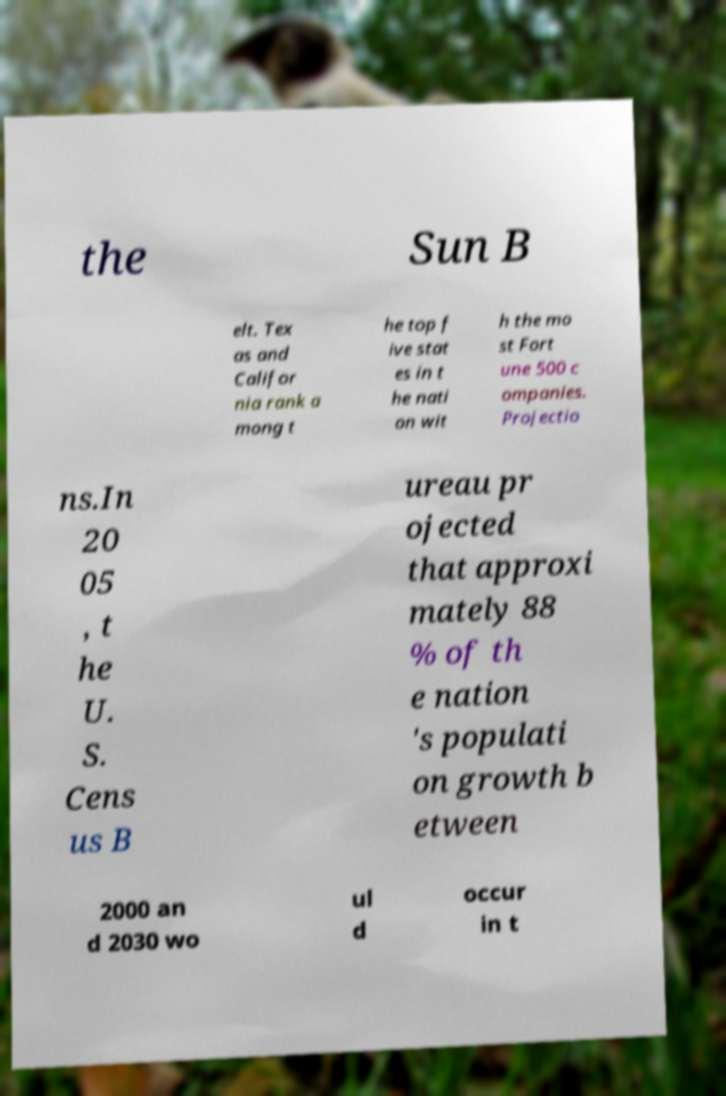There's text embedded in this image that I need extracted. Can you transcribe it verbatim? the Sun B elt. Tex as and Califor nia rank a mong t he top f ive stat es in t he nati on wit h the mo st Fort une 500 c ompanies. Projectio ns.In 20 05 , t he U. S. Cens us B ureau pr ojected that approxi mately 88 % of th e nation 's populati on growth b etween 2000 an d 2030 wo ul d occur in t 